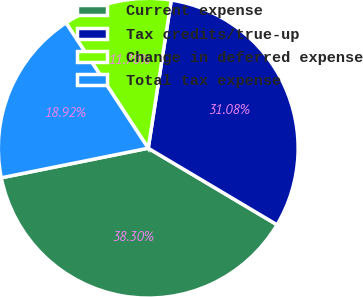Convert chart to OTSL. <chart><loc_0><loc_0><loc_500><loc_500><pie_chart><fcel>Current expense<fcel>Tax credits/true-up<fcel>Change in deferred expense<fcel>Total tax expense<nl><fcel>38.3%<fcel>31.08%<fcel>11.7%<fcel>18.92%<nl></chart> 